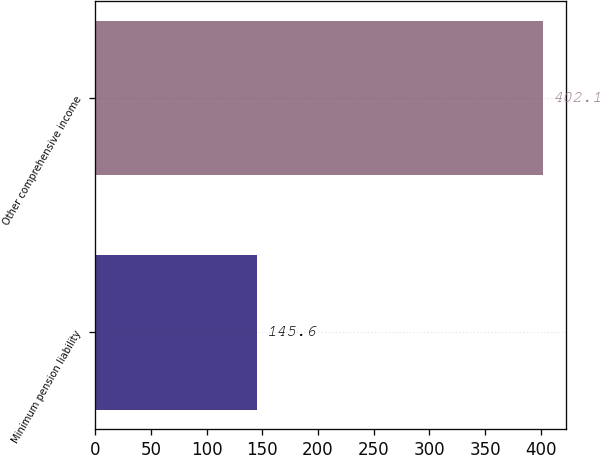Convert chart. <chart><loc_0><loc_0><loc_500><loc_500><bar_chart><fcel>Minimum pension liability<fcel>Other comprehensive income<nl><fcel>145.6<fcel>402.1<nl></chart> 